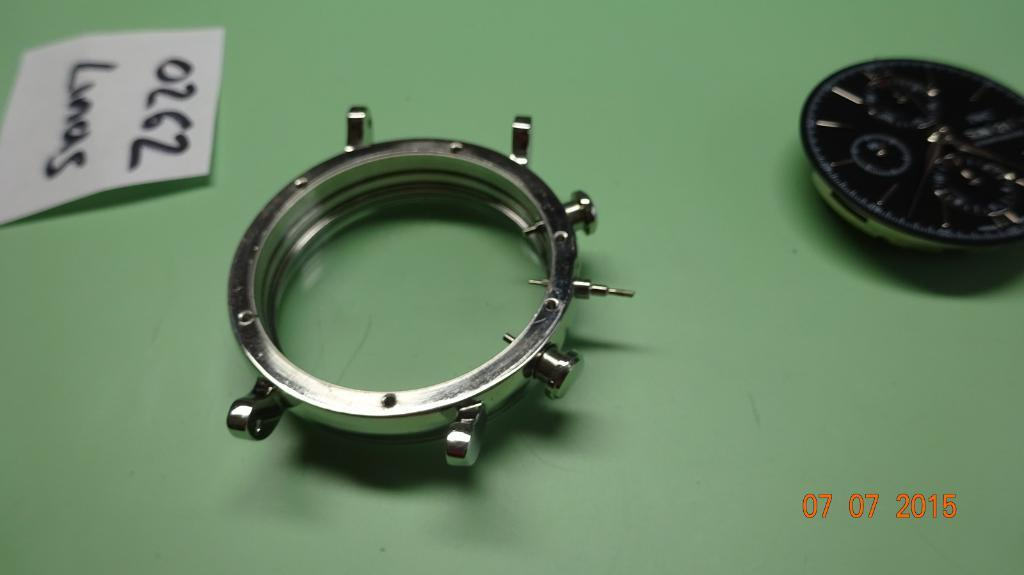What is the main object in the image? There is a table in the image. What is placed on the table? There are parts of a watch on the table. What is on the left side of the table? There is a paper on the left side of the table. What can be read on the paper? There is text on the paper. What additional information can be gathered from the image? The date is visible in the bottom right corner of the image. How does the rake contribute to the watch repair process in the image? There is no rake present in the image, so it cannot contribute to the watch repair process. 